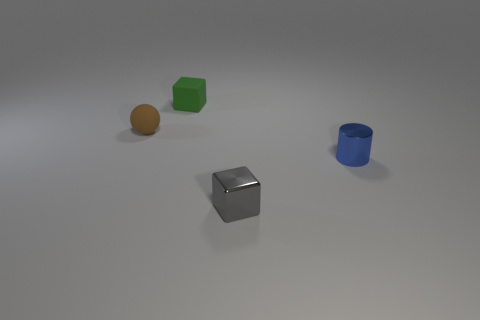Add 4 large red shiny things. How many objects exist? 8 Subtract all balls. How many objects are left? 3 Subtract all tiny blue metallic cylinders. Subtract all big red metallic cylinders. How many objects are left? 3 Add 3 small gray metal things. How many small gray metal things are left? 4 Add 3 big blue objects. How many big blue objects exist? 3 Subtract 0 red blocks. How many objects are left? 4 